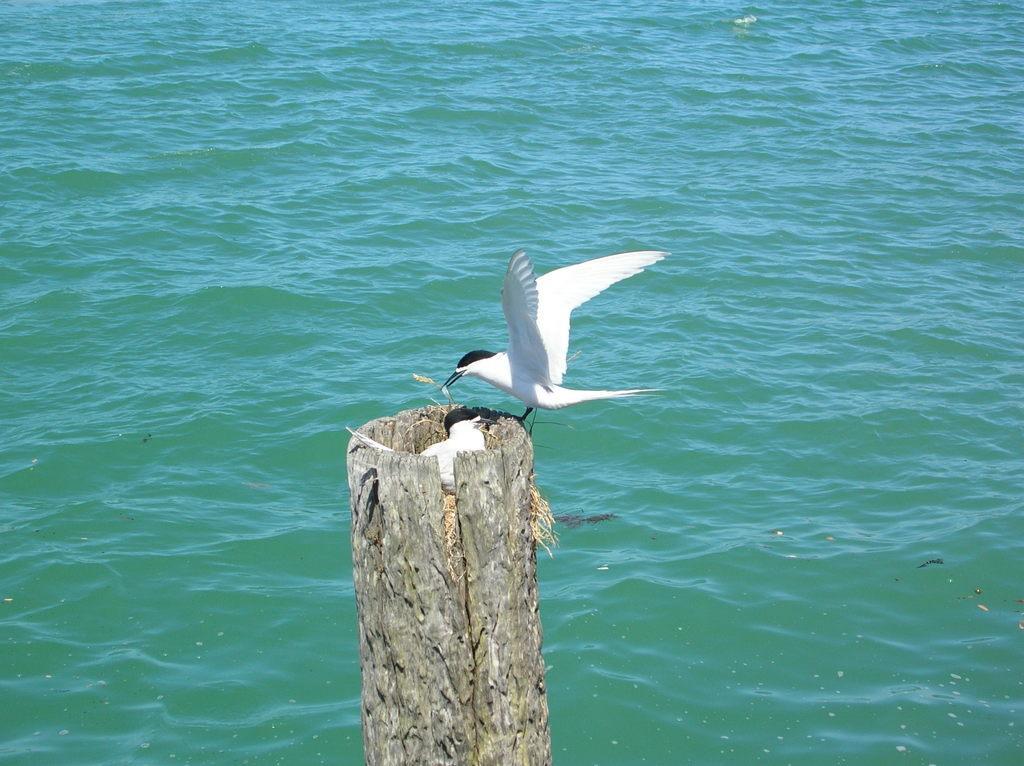How would you summarize this image in a sentence or two? In the foreground of the image we can see a trunk of a tree and water body. In the middle of the image we can see a nest in the trunk and two birds. On the top of the image we can see water body. 